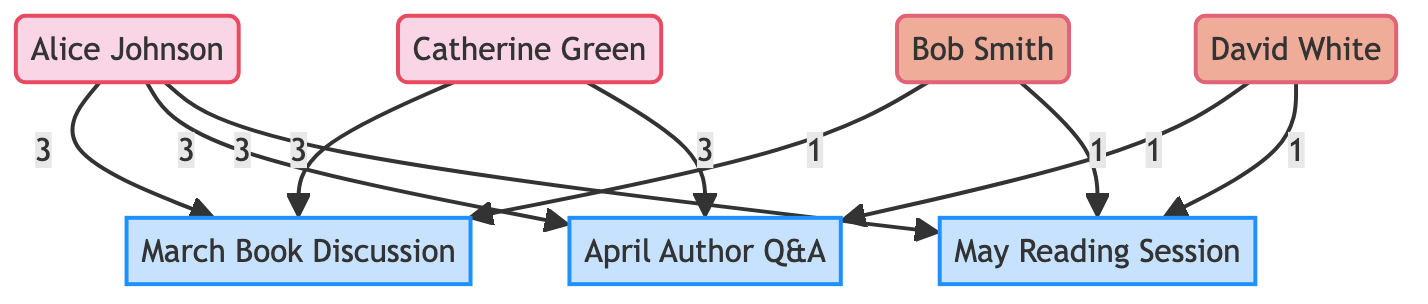What is the total number of members in the diagram? The diagram lists four individual nodes designated as members: Alice Johnson, Bob Smith, Catherine Green, and David White. Therefore, counting these nodes gives us a total of four members.
Answer: 4 Who attended the April Author Q&A event? The April Author Q&A event is connected to the following members: Catherine Green and David White. They are represented as having attended this event, as indicated by the edges connected to event_2.
Answer: Catherine Green, David White How many interactions did Alice Johnson have at the March Book Discussion? The edge between Alice Johnson and the March Book Discussion specifies 3 interactions, which is the value assigned to that edge in the diagram.
Answer: 3 Which member is a sporadic attendee that attended the May Reading Session? The May Reading Session shows that only David White, labeled as a sporadic attendee, is connected to that event. This is confirmed by the edge leading to event_3.
Answer: David White What type of attendee is Catherine Green? The node representing Catherine Green is classified as a frequent attendee, as denoted in the node type definition in the diagram.
Answer: frequent_attendee How many members attended the March Book Discussion event? The March Book Discussion event is attended by Alice Johnson and Catherine Green, both of whom are connected by edges to event_1. Therefore, adding these two connections, we see two members attended.
Answer: 2 Which event had the most frequent attendees? The edges connected to the March Book Discussion show that both Alice Johnson and Catherine Green attended with 3 interactions each, meaning they attended this event most frequently compared to the others.
Answer: March Book Discussion How many events did Bob Smith attend? Bob Smith has two edges connecting him to the events in the diagram - one to the March Book Discussion and one to the May Reading Session. Therefore, he attended a total of two events.
Answer: 2 Which event did David White attend the least? David White attended both the April Author Q&A and the May Reading Session; each shows only 1 interaction. He attended these events the least compared to other connections.
Answer: April Author Q&A, May Reading Session 